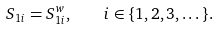Convert formula to latex. <formula><loc_0><loc_0><loc_500><loc_500>S _ { 1 i } = S _ { 1 i } ^ { w } , \quad i \in \{ 1 , 2 , 3 , \dots \} .</formula> 